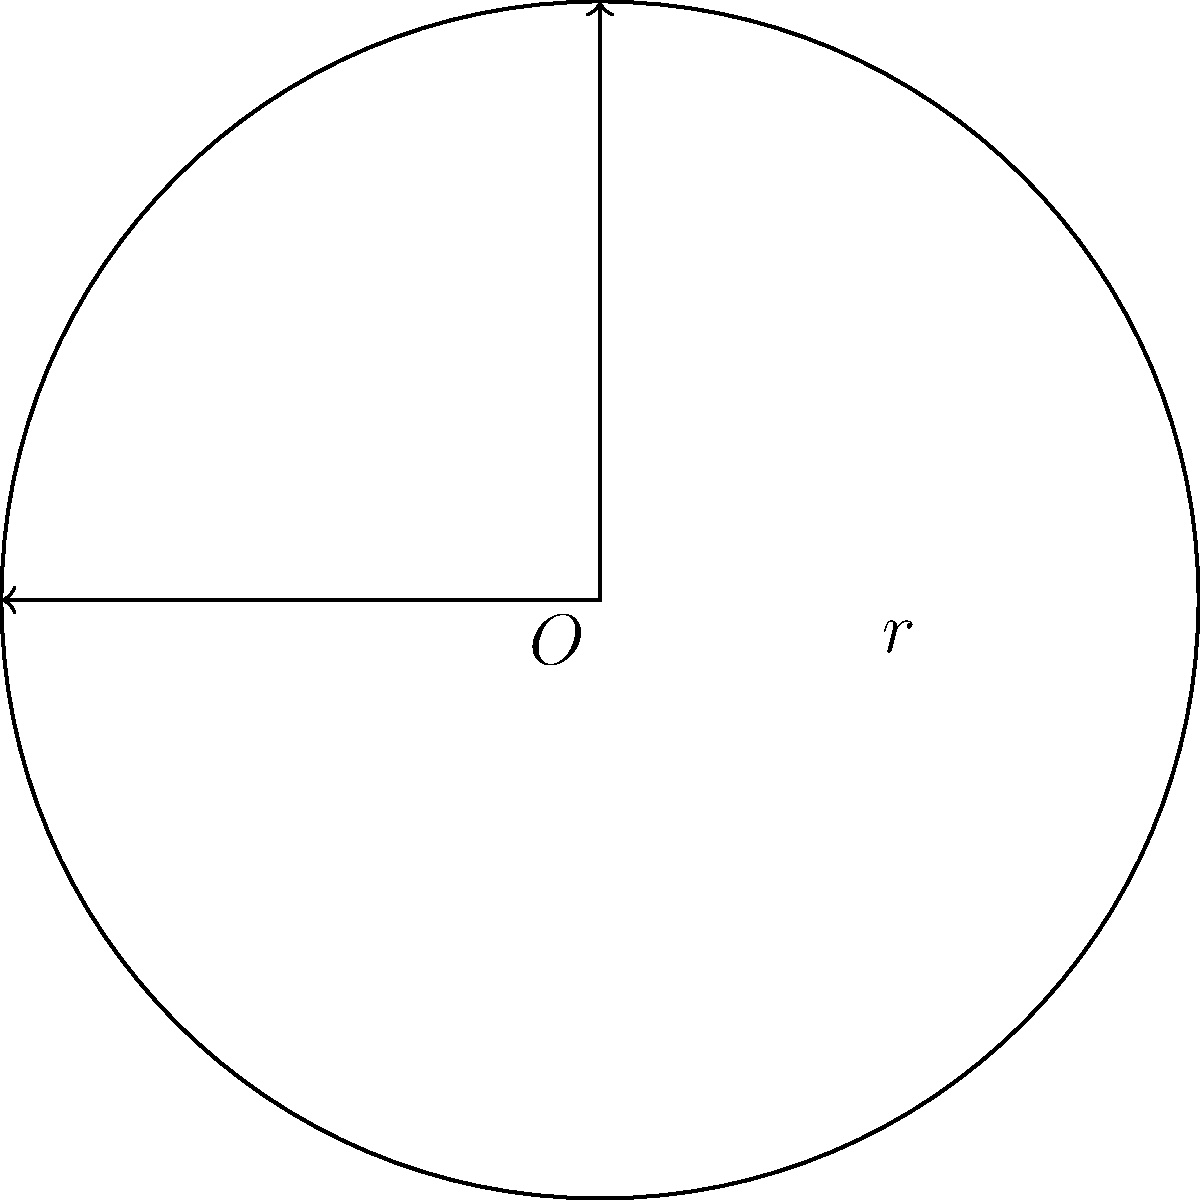At a bachata performance featuring Antony Santos, the stage is circular with a radius of 5 meters. If the dancers need to move along the edge of the stage for a full rotation, what is the distance they will travel? (Use $\pi \approx 3.14$) To find the distance the dancers will travel along the edge of the circular stage, we need to calculate the circumference of the circle. Let's follow these steps:

1. Recall the formula for the circumference of a circle:
   $C = 2\pi r$, where $C$ is the circumference and $r$ is the radius.

2. We are given that the radius is 5 meters and $\pi \approx 3.14$.

3. Let's substitute these values into the formula:
   $C = 2 \times 3.14 \times 5$

4. Multiply:
   $C = 6.28 \times 5 = 31.4$

5. Therefore, the circumference of the stage, which is the distance the dancers will travel for a full rotation, is 31.4 meters.
Answer: 31.4 meters 